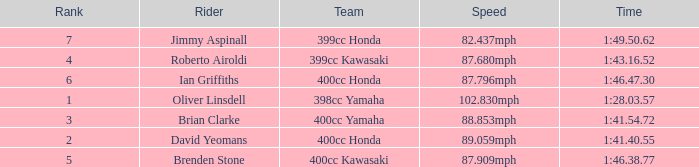What is the time of the rider ranked 6? 1:46.47.30. 